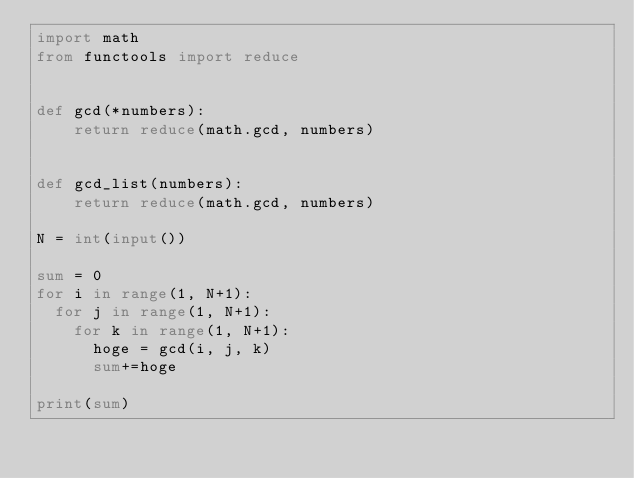Convert code to text. <code><loc_0><loc_0><loc_500><loc_500><_Python_>import math
from functools import reduce


def gcd(*numbers):
    return reduce(math.gcd, numbers)


def gcd_list(numbers):
    return reduce(math.gcd, numbers)

N = int(input())

sum = 0
for i in range(1, N+1):
  for j in range(1, N+1):
    for k in range(1, N+1):
      hoge = gcd(i, j, k)
      sum+=hoge

print(sum)
</code> 